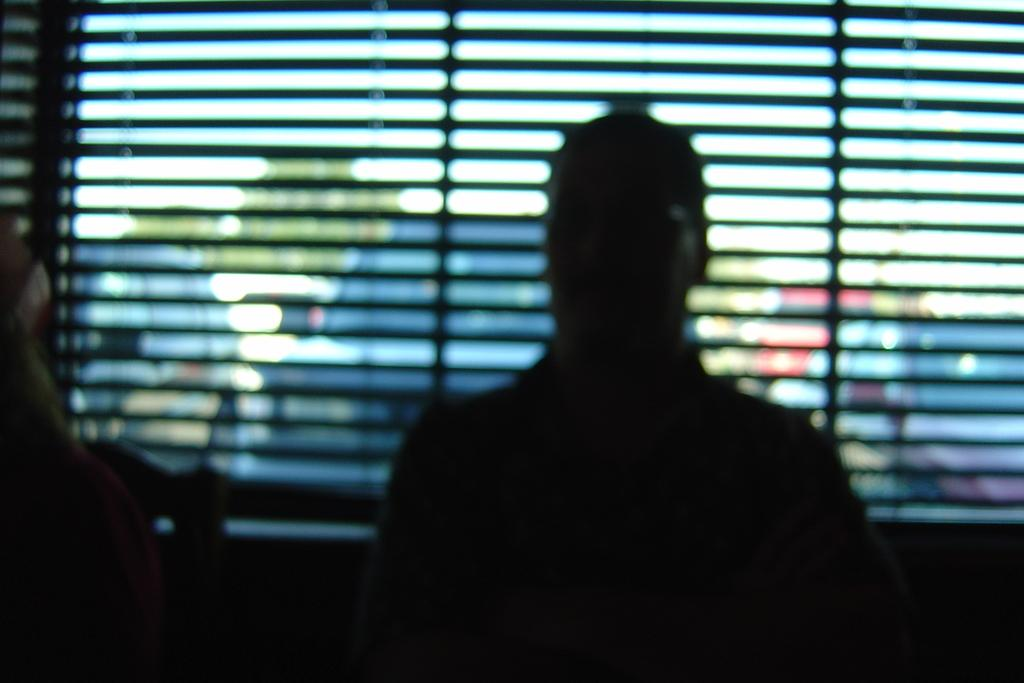What types of objects can be seen in the image? There are vehicles in the image. Can you see a squirrel driving one of the vehicles in the image? There is no squirrel present in the image, and therefore no squirrel driving a vehicle can be observed. 